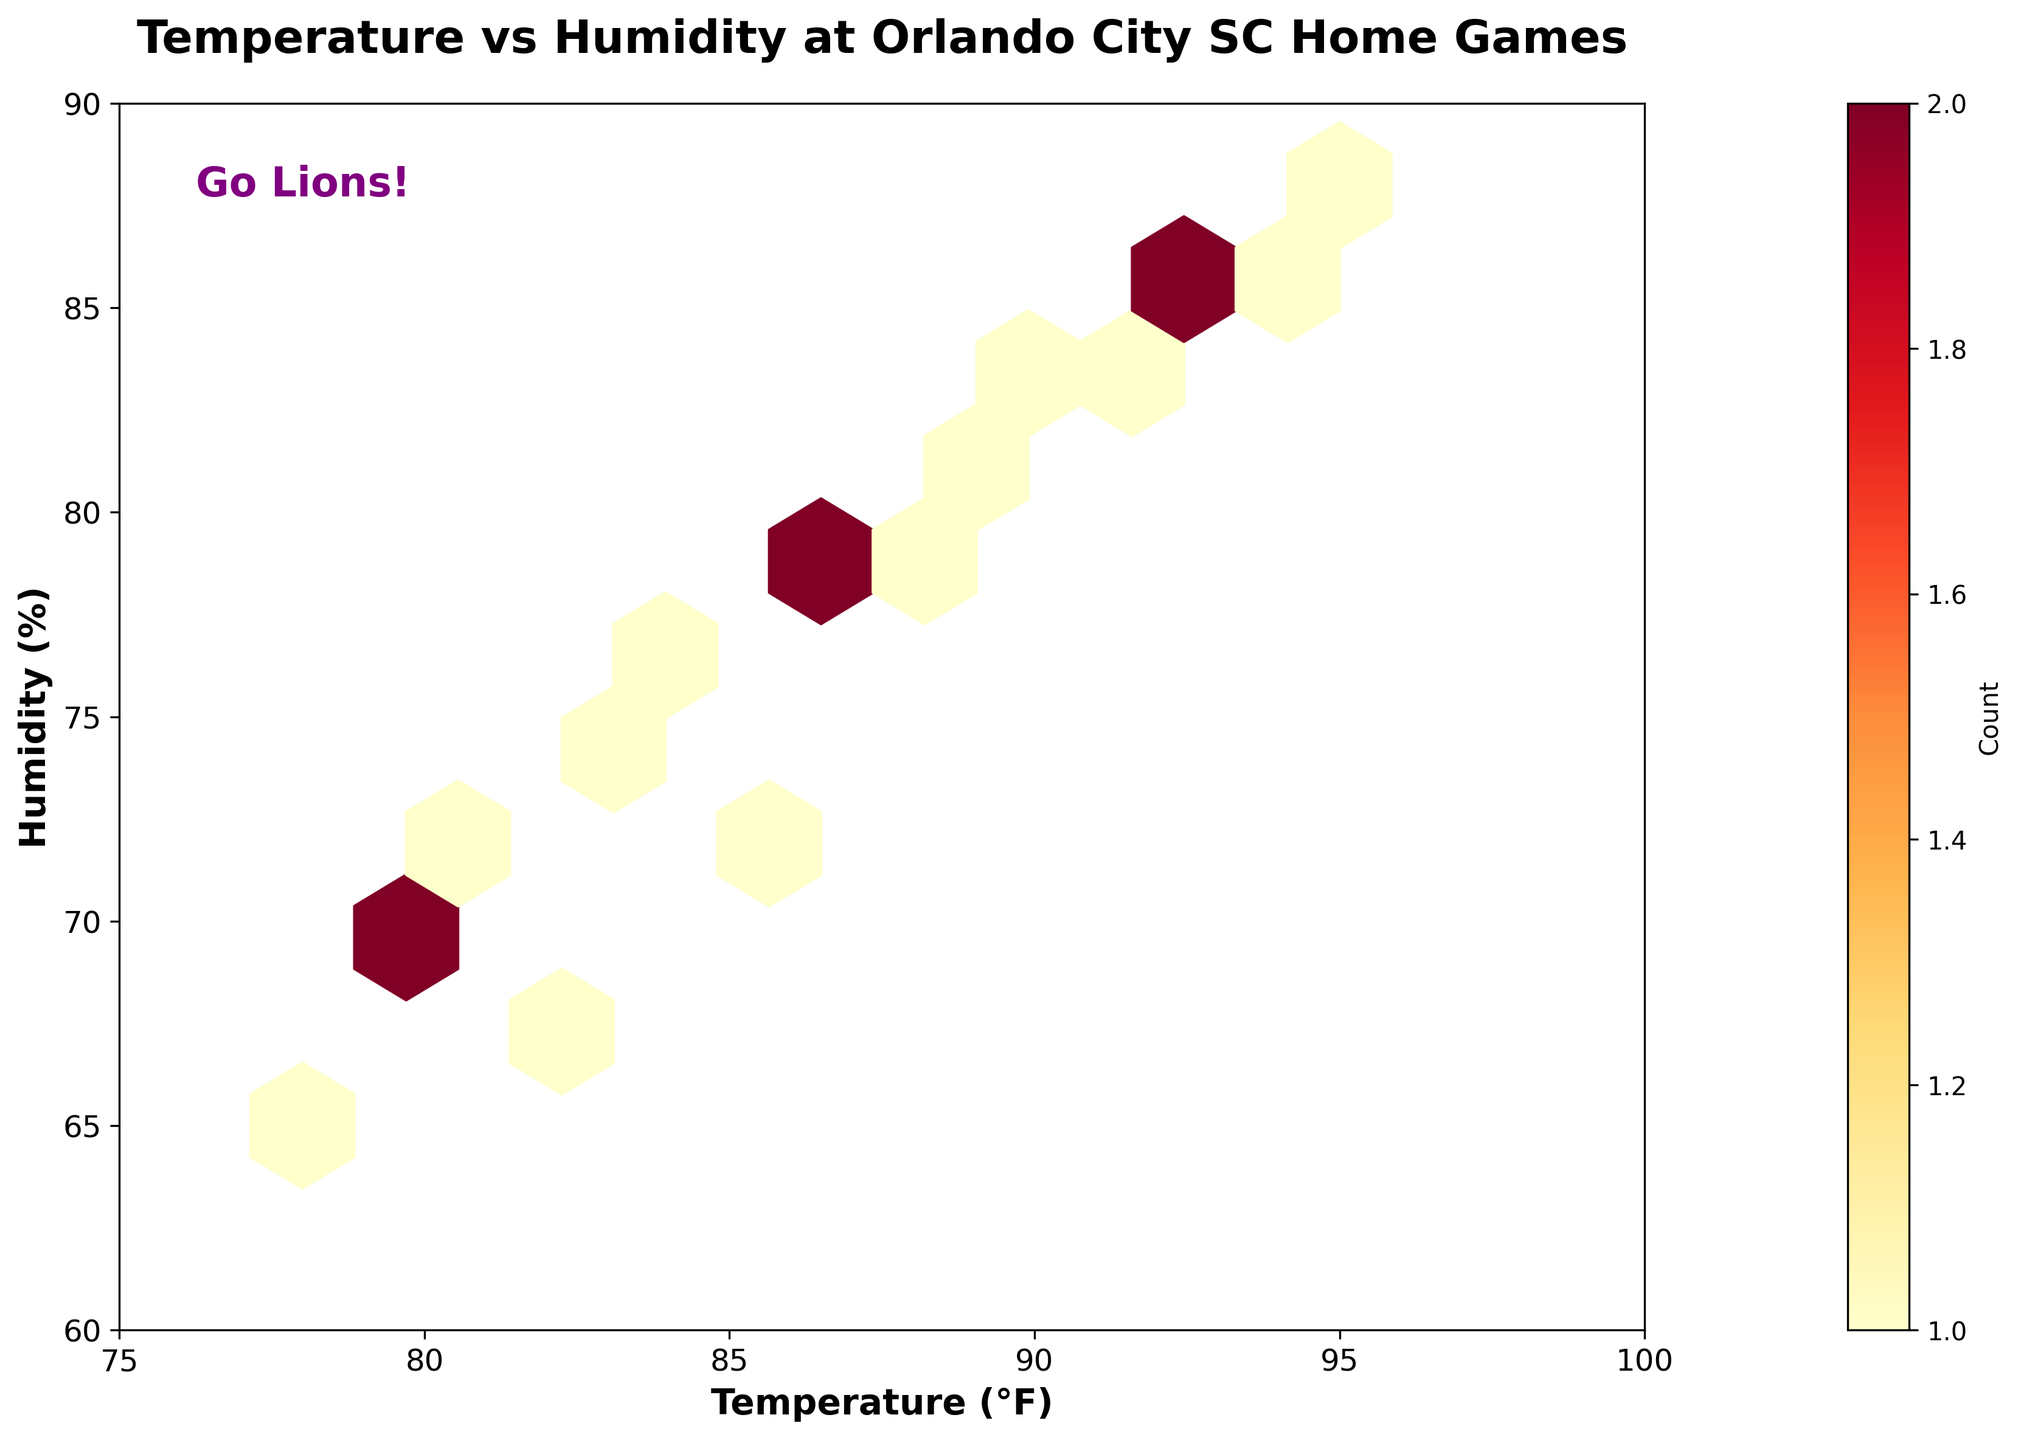What is the title of the hexbin plot? The figure title is typically found at the top of the plot. Here, it is set during the plot creation process.
Answer: Temperature vs Humidity at Orlando City SC Home Games What do the x-axis and y-axis labels represent? The axis labels are visible to provide context; the x-axis is labeled 'Temperature (°F)' and the y-axis is labeled 'Humidity (%)'.
Answer: Temperature (°F) and Humidity (%) How many temperature and humidity hexagonal bins contain data? Looking at the figure, count the filled hexagonal bins, as empty bins are not included due to the mincnt parameter set to 1.
Answer: Multiple bins Which section of the plot has the highest density of data points? The plot visualizes data density using color intensity. The area with the darkest color signifies the highest density.
Answer: Near the center, around 85-90°F and 75-80% What color scheme is used in the hexbin plot? The color scheme is evident from examining the bins and the color bar; it ranges from light yellow/orange to red, indicating varying densities.
Answer: Yellow to red (YlOrRd) Between what temperature and humidity ranges does most of the data concentrate? Most data points lie in the hexagons with the highest density. Visually inspecting the central dense area provides the range.
Answer: 85-90°F and 75-80% How many bins show a count of data points greater than 2? Utilizing the color bar, observe the number of bins that are colored in a way that represents counts greater than 2.
Answer: Several bins What trend or pattern can you observe between temperature and humidity during the games? Evaluate the overall distribution of hexagons; a general upward trend or concentration in certain sectors can imply a relationship.
Answer: Higher temperatures correlate with higher humidity How does the temperature in early March compare to mid-July at home games? Refer to individual dates; March temperatures are in the low 80s, while July temperatures reach the mid-90s, reflecting a significant increase.
Answer: July is hotter than March What do the axes' limits indicate about the range of recorded temperatures and humidity levels? The axes' limits give an overview of the full range of data; here from 75°F to 100°F for temperature and 60% to 90% for humidity.
Answer: Temperature 75-100°F, Humidity 60-90% 